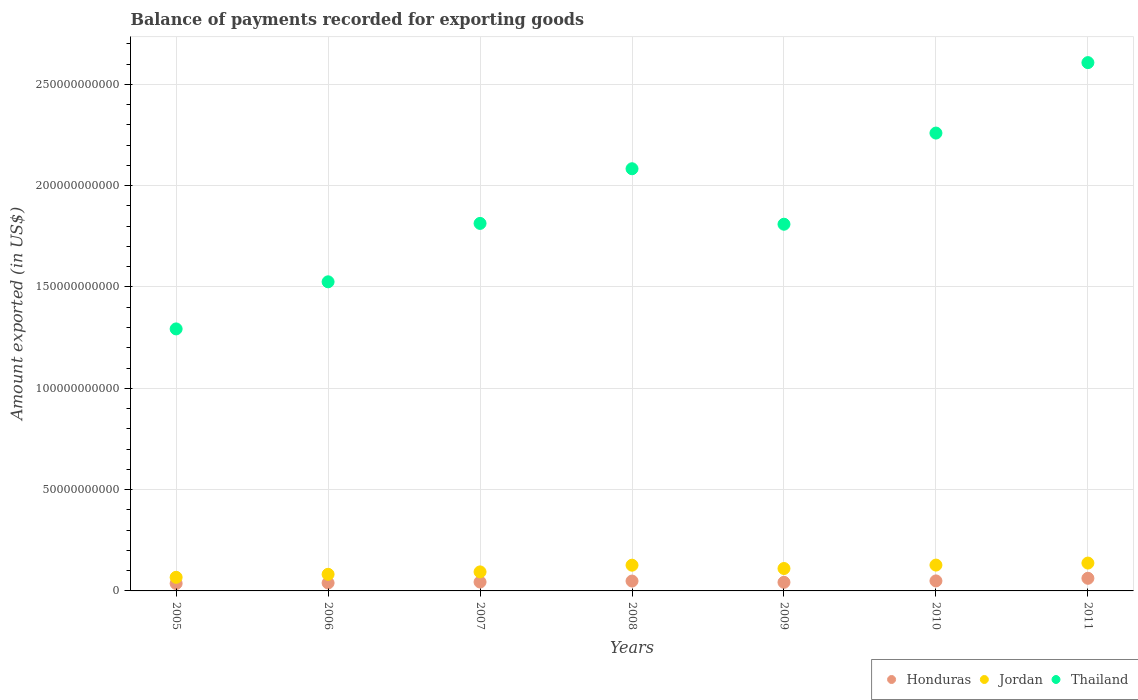How many different coloured dotlines are there?
Your response must be concise. 3. What is the amount exported in Honduras in 2005?
Keep it short and to the point. 3.67e+09. Across all years, what is the maximum amount exported in Honduras?
Your answer should be very brief. 6.23e+09. Across all years, what is the minimum amount exported in Jordan?
Your answer should be very brief. 6.71e+09. What is the total amount exported in Thailand in the graph?
Keep it short and to the point. 1.34e+12. What is the difference between the amount exported in Honduras in 2006 and that in 2008?
Your answer should be compact. -9.28e+08. What is the difference between the amount exported in Honduras in 2006 and the amount exported in Jordan in 2007?
Ensure brevity in your answer.  -5.45e+09. What is the average amount exported in Thailand per year?
Your answer should be very brief. 1.91e+11. In the year 2005, what is the difference between the amount exported in Thailand and amount exported in Jordan?
Offer a terse response. 1.23e+11. What is the ratio of the amount exported in Honduras in 2006 to that in 2010?
Provide a short and direct response. 0.8. Is the amount exported in Thailand in 2010 less than that in 2011?
Provide a succinct answer. Yes. Is the difference between the amount exported in Thailand in 2005 and 2010 greater than the difference between the amount exported in Jordan in 2005 and 2010?
Keep it short and to the point. No. What is the difference between the highest and the second highest amount exported in Thailand?
Keep it short and to the point. 3.48e+1. What is the difference between the highest and the lowest amount exported in Jordan?
Provide a short and direct response. 7.03e+09. Is the sum of the amount exported in Thailand in 2008 and 2009 greater than the maximum amount exported in Jordan across all years?
Ensure brevity in your answer.  Yes. Is it the case that in every year, the sum of the amount exported in Jordan and amount exported in Honduras  is greater than the amount exported in Thailand?
Your answer should be compact. No. Is the amount exported in Thailand strictly less than the amount exported in Honduras over the years?
Keep it short and to the point. No. How many dotlines are there?
Offer a very short reply. 3. How many years are there in the graph?
Provide a succinct answer. 7. Does the graph contain any zero values?
Your response must be concise. No. Where does the legend appear in the graph?
Your answer should be very brief. Bottom right. What is the title of the graph?
Provide a short and direct response. Balance of payments recorded for exporting goods. Does "Bahrain" appear as one of the legend labels in the graph?
Your answer should be compact. No. What is the label or title of the Y-axis?
Provide a succinct answer. Amount exported (in US$). What is the Amount exported (in US$) in Honduras in 2005?
Ensure brevity in your answer.  3.67e+09. What is the Amount exported (in US$) of Jordan in 2005?
Make the answer very short. 6.71e+09. What is the Amount exported (in US$) in Thailand in 2005?
Your response must be concise. 1.29e+11. What is the Amount exported (in US$) in Honduras in 2006?
Provide a short and direct response. 3.94e+09. What is the Amount exported (in US$) in Jordan in 2006?
Your answer should be compact. 8.20e+09. What is the Amount exported (in US$) in Thailand in 2006?
Make the answer very short. 1.53e+11. What is the Amount exported (in US$) in Honduras in 2007?
Offer a terse response. 4.38e+09. What is the Amount exported (in US$) of Jordan in 2007?
Your response must be concise. 9.39e+09. What is the Amount exported (in US$) in Thailand in 2007?
Offer a terse response. 1.81e+11. What is the Amount exported (in US$) in Honduras in 2008?
Your response must be concise. 4.87e+09. What is the Amount exported (in US$) of Jordan in 2008?
Offer a very short reply. 1.27e+1. What is the Amount exported (in US$) of Thailand in 2008?
Your answer should be very brief. 2.08e+11. What is the Amount exported (in US$) of Honduras in 2009?
Offer a very short reply. 4.25e+09. What is the Amount exported (in US$) of Jordan in 2009?
Give a very brief answer. 1.11e+1. What is the Amount exported (in US$) in Thailand in 2009?
Make the answer very short. 1.81e+11. What is the Amount exported (in US$) in Honduras in 2010?
Offer a very short reply. 4.94e+09. What is the Amount exported (in US$) in Jordan in 2010?
Your answer should be very brief. 1.28e+1. What is the Amount exported (in US$) of Thailand in 2010?
Provide a short and direct response. 2.26e+11. What is the Amount exported (in US$) in Honduras in 2011?
Keep it short and to the point. 6.23e+09. What is the Amount exported (in US$) of Jordan in 2011?
Offer a very short reply. 1.37e+1. What is the Amount exported (in US$) of Thailand in 2011?
Provide a short and direct response. 2.61e+11. Across all years, what is the maximum Amount exported (in US$) in Honduras?
Ensure brevity in your answer.  6.23e+09. Across all years, what is the maximum Amount exported (in US$) in Jordan?
Keep it short and to the point. 1.37e+1. Across all years, what is the maximum Amount exported (in US$) in Thailand?
Provide a succinct answer. 2.61e+11. Across all years, what is the minimum Amount exported (in US$) in Honduras?
Your answer should be very brief. 3.67e+09. Across all years, what is the minimum Amount exported (in US$) in Jordan?
Your response must be concise. 6.71e+09. Across all years, what is the minimum Amount exported (in US$) in Thailand?
Your answer should be very brief. 1.29e+11. What is the total Amount exported (in US$) in Honduras in the graph?
Ensure brevity in your answer.  3.23e+1. What is the total Amount exported (in US$) in Jordan in the graph?
Your answer should be very brief. 7.46e+1. What is the total Amount exported (in US$) of Thailand in the graph?
Ensure brevity in your answer.  1.34e+12. What is the difference between the Amount exported (in US$) in Honduras in 2005 and that in 2006?
Make the answer very short. -2.66e+08. What is the difference between the Amount exported (in US$) of Jordan in 2005 and that in 2006?
Ensure brevity in your answer.  -1.49e+09. What is the difference between the Amount exported (in US$) in Thailand in 2005 and that in 2006?
Provide a short and direct response. -2.32e+1. What is the difference between the Amount exported (in US$) in Honduras in 2005 and that in 2007?
Your response must be concise. -7.13e+08. What is the difference between the Amount exported (in US$) of Jordan in 2005 and that in 2007?
Make the answer very short. -2.67e+09. What is the difference between the Amount exported (in US$) of Thailand in 2005 and that in 2007?
Keep it short and to the point. -5.21e+1. What is the difference between the Amount exported (in US$) in Honduras in 2005 and that in 2008?
Keep it short and to the point. -1.19e+09. What is the difference between the Amount exported (in US$) of Jordan in 2005 and that in 2008?
Your answer should be compact. -5.99e+09. What is the difference between the Amount exported (in US$) in Thailand in 2005 and that in 2008?
Give a very brief answer. -7.90e+1. What is the difference between the Amount exported (in US$) of Honduras in 2005 and that in 2009?
Your answer should be compact. -5.75e+08. What is the difference between the Amount exported (in US$) of Jordan in 2005 and that in 2009?
Your response must be concise. -4.35e+09. What is the difference between the Amount exported (in US$) in Thailand in 2005 and that in 2009?
Offer a terse response. -5.17e+1. What is the difference between the Amount exported (in US$) in Honduras in 2005 and that in 2010?
Offer a very short reply. -1.27e+09. What is the difference between the Amount exported (in US$) of Jordan in 2005 and that in 2010?
Your answer should be compact. -6.04e+09. What is the difference between the Amount exported (in US$) of Thailand in 2005 and that in 2010?
Your answer should be very brief. -9.66e+1. What is the difference between the Amount exported (in US$) of Honduras in 2005 and that in 2011?
Ensure brevity in your answer.  -2.56e+09. What is the difference between the Amount exported (in US$) of Jordan in 2005 and that in 2011?
Give a very brief answer. -7.03e+09. What is the difference between the Amount exported (in US$) in Thailand in 2005 and that in 2011?
Keep it short and to the point. -1.31e+11. What is the difference between the Amount exported (in US$) of Honduras in 2006 and that in 2007?
Give a very brief answer. -4.47e+08. What is the difference between the Amount exported (in US$) of Jordan in 2006 and that in 2007?
Provide a succinct answer. -1.19e+09. What is the difference between the Amount exported (in US$) of Thailand in 2006 and that in 2007?
Keep it short and to the point. -2.88e+1. What is the difference between the Amount exported (in US$) of Honduras in 2006 and that in 2008?
Provide a succinct answer. -9.28e+08. What is the difference between the Amount exported (in US$) of Jordan in 2006 and that in 2008?
Your answer should be very brief. -4.50e+09. What is the difference between the Amount exported (in US$) of Thailand in 2006 and that in 2008?
Give a very brief answer. -5.58e+1. What is the difference between the Amount exported (in US$) in Honduras in 2006 and that in 2009?
Make the answer very short. -3.09e+08. What is the difference between the Amount exported (in US$) of Jordan in 2006 and that in 2009?
Offer a very short reply. -2.86e+09. What is the difference between the Amount exported (in US$) in Thailand in 2006 and that in 2009?
Give a very brief answer. -2.84e+1. What is the difference between the Amount exported (in US$) of Honduras in 2006 and that in 2010?
Your answer should be compact. -1.00e+09. What is the difference between the Amount exported (in US$) of Jordan in 2006 and that in 2010?
Offer a terse response. -4.55e+09. What is the difference between the Amount exported (in US$) of Thailand in 2006 and that in 2010?
Provide a succinct answer. -7.34e+1. What is the difference between the Amount exported (in US$) in Honduras in 2006 and that in 2011?
Offer a very short reply. -2.29e+09. What is the difference between the Amount exported (in US$) of Jordan in 2006 and that in 2011?
Your answer should be very brief. -5.54e+09. What is the difference between the Amount exported (in US$) of Thailand in 2006 and that in 2011?
Offer a very short reply. -1.08e+11. What is the difference between the Amount exported (in US$) in Honduras in 2007 and that in 2008?
Your response must be concise. -4.81e+08. What is the difference between the Amount exported (in US$) of Jordan in 2007 and that in 2008?
Offer a very short reply. -3.31e+09. What is the difference between the Amount exported (in US$) in Thailand in 2007 and that in 2008?
Offer a terse response. -2.70e+1. What is the difference between the Amount exported (in US$) of Honduras in 2007 and that in 2009?
Offer a very short reply. 1.38e+08. What is the difference between the Amount exported (in US$) of Jordan in 2007 and that in 2009?
Give a very brief answer. -1.67e+09. What is the difference between the Amount exported (in US$) in Thailand in 2007 and that in 2009?
Give a very brief answer. 4.05e+08. What is the difference between the Amount exported (in US$) in Honduras in 2007 and that in 2010?
Keep it short and to the point. -5.55e+08. What is the difference between the Amount exported (in US$) in Jordan in 2007 and that in 2010?
Make the answer very short. -3.36e+09. What is the difference between the Amount exported (in US$) of Thailand in 2007 and that in 2010?
Provide a short and direct response. -4.46e+1. What is the difference between the Amount exported (in US$) in Honduras in 2007 and that in 2011?
Your answer should be very brief. -1.85e+09. What is the difference between the Amount exported (in US$) of Jordan in 2007 and that in 2011?
Provide a short and direct response. -4.36e+09. What is the difference between the Amount exported (in US$) in Thailand in 2007 and that in 2011?
Your answer should be compact. -7.93e+1. What is the difference between the Amount exported (in US$) in Honduras in 2008 and that in 2009?
Make the answer very short. 6.19e+08. What is the difference between the Amount exported (in US$) of Jordan in 2008 and that in 2009?
Make the answer very short. 1.64e+09. What is the difference between the Amount exported (in US$) in Thailand in 2008 and that in 2009?
Give a very brief answer. 2.74e+1. What is the difference between the Amount exported (in US$) in Honduras in 2008 and that in 2010?
Your answer should be compact. -7.41e+07. What is the difference between the Amount exported (in US$) of Jordan in 2008 and that in 2010?
Keep it short and to the point. -5.28e+07. What is the difference between the Amount exported (in US$) in Thailand in 2008 and that in 2010?
Make the answer very short. -1.76e+1. What is the difference between the Amount exported (in US$) of Honduras in 2008 and that in 2011?
Give a very brief answer. -1.37e+09. What is the difference between the Amount exported (in US$) in Jordan in 2008 and that in 2011?
Offer a terse response. -1.04e+09. What is the difference between the Amount exported (in US$) in Thailand in 2008 and that in 2011?
Provide a short and direct response. -5.24e+1. What is the difference between the Amount exported (in US$) in Honduras in 2009 and that in 2010?
Your response must be concise. -6.93e+08. What is the difference between the Amount exported (in US$) in Jordan in 2009 and that in 2010?
Provide a short and direct response. -1.69e+09. What is the difference between the Amount exported (in US$) of Thailand in 2009 and that in 2010?
Make the answer very short. -4.50e+1. What is the difference between the Amount exported (in US$) in Honduras in 2009 and that in 2011?
Provide a succinct answer. -1.99e+09. What is the difference between the Amount exported (in US$) in Jordan in 2009 and that in 2011?
Ensure brevity in your answer.  -2.68e+09. What is the difference between the Amount exported (in US$) in Thailand in 2009 and that in 2011?
Give a very brief answer. -7.97e+1. What is the difference between the Amount exported (in US$) of Honduras in 2010 and that in 2011?
Your answer should be compact. -1.29e+09. What is the difference between the Amount exported (in US$) in Jordan in 2010 and that in 2011?
Make the answer very short. -9.92e+08. What is the difference between the Amount exported (in US$) in Thailand in 2010 and that in 2011?
Provide a short and direct response. -3.48e+1. What is the difference between the Amount exported (in US$) of Honduras in 2005 and the Amount exported (in US$) of Jordan in 2006?
Provide a short and direct response. -4.53e+09. What is the difference between the Amount exported (in US$) of Honduras in 2005 and the Amount exported (in US$) of Thailand in 2006?
Offer a terse response. -1.49e+11. What is the difference between the Amount exported (in US$) in Jordan in 2005 and the Amount exported (in US$) in Thailand in 2006?
Your answer should be very brief. -1.46e+11. What is the difference between the Amount exported (in US$) in Honduras in 2005 and the Amount exported (in US$) in Jordan in 2007?
Ensure brevity in your answer.  -5.72e+09. What is the difference between the Amount exported (in US$) in Honduras in 2005 and the Amount exported (in US$) in Thailand in 2007?
Keep it short and to the point. -1.78e+11. What is the difference between the Amount exported (in US$) in Jordan in 2005 and the Amount exported (in US$) in Thailand in 2007?
Give a very brief answer. -1.75e+11. What is the difference between the Amount exported (in US$) of Honduras in 2005 and the Amount exported (in US$) of Jordan in 2008?
Offer a terse response. -9.03e+09. What is the difference between the Amount exported (in US$) in Honduras in 2005 and the Amount exported (in US$) in Thailand in 2008?
Your answer should be very brief. -2.05e+11. What is the difference between the Amount exported (in US$) in Jordan in 2005 and the Amount exported (in US$) in Thailand in 2008?
Give a very brief answer. -2.02e+11. What is the difference between the Amount exported (in US$) of Honduras in 2005 and the Amount exported (in US$) of Jordan in 2009?
Provide a succinct answer. -7.39e+09. What is the difference between the Amount exported (in US$) in Honduras in 2005 and the Amount exported (in US$) in Thailand in 2009?
Your response must be concise. -1.77e+11. What is the difference between the Amount exported (in US$) of Jordan in 2005 and the Amount exported (in US$) of Thailand in 2009?
Offer a terse response. -1.74e+11. What is the difference between the Amount exported (in US$) of Honduras in 2005 and the Amount exported (in US$) of Jordan in 2010?
Keep it short and to the point. -9.08e+09. What is the difference between the Amount exported (in US$) of Honduras in 2005 and the Amount exported (in US$) of Thailand in 2010?
Keep it short and to the point. -2.22e+11. What is the difference between the Amount exported (in US$) in Jordan in 2005 and the Amount exported (in US$) in Thailand in 2010?
Your answer should be very brief. -2.19e+11. What is the difference between the Amount exported (in US$) of Honduras in 2005 and the Amount exported (in US$) of Jordan in 2011?
Ensure brevity in your answer.  -1.01e+1. What is the difference between the Amount exported (in US$) in Honduras in 2005 and the Amount exported (in US$) in Thailand in 2011?
Offer a terse response. -2.57e+11. What is the difference between the Amount exported (in US$) in Jordan in 2005 and the Amount exported (in US$) in Thailand in 2011?
Make the answer very short. -2.54e+11. What is the difference between the Amount exported (in US$) of Honduras in 2006 and the Amount exported (in US$) of Jordan in 2007?
Offer a terse response. -5.45e+09. What is the difference between the Amount exported (in US$) of Honduras in 2006 and the Amount exported (in US$) of Thailand in 2007?
Provide a succinct answer. -1.77e+11. What is the difference between the Amount exported (in US$) of Jordan in 2006 and the Amount exported (in US$) of Thailand in 2007?
Your response must be concise. -1.73e+11. What is the difference between the Amount exported (in US$) of Honduras in 2006 and the Amount exported (in US$) of Jordan in 2008?
Offer a terse response. -8.76e+09. What is the difference between the Amount exported (in US$) in Honduras in 2006 and the Amount exported (in US$) in Thailand in 2008?
Give a very brief answer. -2.04e+11. What is the difference between the Amount exported (in US$) of Jordan in 2006 and the Amount exported (in US$) of Thailand in 2008?
Give a very brief answer. -2.00e+11. What is the difference between the Amount exported (in US$) of Honduras in 2006 and the Amount exported (in US$) of Jordan in 2009?
Offer a very short reply. -7.12e+09. What is the difference between the Amount exported (in US$) of Honduras in 2006 and the Amount exported (in US$) of Thailand in 2009?
Make the answer very short. -1.77e+11. What is the difference between the Amount exported (in US$) in Jordan in 2006 and the Amount exported (in US$) in Thailand in 2009?
Offer a very short reply. -1.73e+11. What is the difference between the Amount exported (in US$) of Honduras in 2006 and the Amount exported (in US$) of Jordan in 2010?
Offer a terse response. -8.81e+09. What is the difference between the Amount exported (in US$) in Honduras in 2006 and the Amount exported (in US$) in Thailand in 2010?
Provide a short and direct response. -2.22e+11. What is the difference between the Amount exported (in US$) in Jordan in 2006 and the Amount exported (in US$) in Thailand in 2010?
Keep it short and to the point. -2.18e+11. What is the difference between the Amount exported (in US$) of Honduras in 2006 and the Amount exported (in US$) of Jordan in 2011?
Keep it short and to the point. -9.81e+09. What is the difference between the Amount exported (in US$) in Honduras in 2006 and the Amount exported (in US$) in Thailand in 2011?
Offer a very short reply. -2.57e+11. What is the difference between the Amount exported (in US$) in Jordan in 2006 and the Amount exported (in US$) in Thailand in 2011?
Your answer should be very brief. -2.52e+11. What is the difference between the Amount exported (in US$) in Honduras in 2007 and the Amount exported (in US$) in Jordan in 2008?
Provide a short and direct response. -8.31e+09. What is the difference between the Amount exported (in US$) of Honduras in 2007 and the Amount exported (in US$) of Thailand in 2008?
Ensure brevity in your answer.  -2.04e+11. What is the difference between the Amount exported (in US$) of Jordan in 2007 and the Amount exported (in US$) of Thailand in 2008?
Offer a very short reply. -1.99e+11. What is the difference between the Amount exported (in US$) of Honduras in 2007 and the Amount exported (in US$) of Jordan in 2009?
Keep it short and to the point. -6.68e+09. What is the difference between the Amount exported (in US$) of Honduras in 2007 and the Amount exported (in US$) of Thailand in 2009?
Your response must be concise. -1.77e+11. What is the difference between the Amount exported (in US$) of Jordan in 2007 and the Amount exported (in US$) of Thailand in 2009?
Offer a terse response. -1.72e+11. What is the difference between the Amount exported (in US$) of Honduras in 2007 and the Amount exported (in US$) of Jordan in 2010?
Offer a terse response. -8.37e+09. What is the difference between the Amount exported (in US$) of Honduras in 2007 and the Amount exported (in US$) of Thailand in 2010?
Your answer should be compact. -2.22e+11. What is the difference between the Amount exported (in US$) of Jordan in 2007 and the Amount exported (in US$) of Thailand in 2010?
Provide a short and direct response. -2.17e+11. What is the difference between the Amount exported (in US$) in Honduras in 2007 and the Amount exported (in US$) in Jordan in 2011?
Your response must be concise. -9.36e+09. What is the difference between the Amount exported (in US$) of Honduras in 2007 and the Amount exported (in US$) of Thailand in 2011?
Provide a short and direct response. -2.56e+11. What is the difference between the Amount exported (in US$) of Jordan in 2007 and the Amount exported (in US$) of Thailand in 2011?
Give a very brief answer. -2.51e+11. What is the difference between the Amount exported (in US$) in Honduras in 2008 and the Amount exported (in US$) in Jordan in 2009?
Your response must be concise. -6.20e+09. What is the difference between the Amount exported (in US$) in Honduras in 2008 and the Amount exported (in US$) in Thailand in 2009?
Offer a terse response. -1.76e+11. What is the difference between the Amount exported (in US$) in Jordan in 2008 and the Amount exported (in US$) in Thailand in 2009?
Your response must be concise. -1.68e+11. What is the difference between the Amount exported (in US$) of Honduras in 2008 and the Amount exported (in US$) of Jordan in 2010?
Offer a very short reply. -7.89e+09. What is the difference between the Amount exported (in US$) of Honduras in 2008 and the Amount exported (in US$) of Thailand in 2010?
Provide a short and direct response. -2.21e+11. What is the difference between the Amount exported (in US$) in Jordan in 2008 and the Amount exported (in US$) in Thailand in 2010?
Keep it short and to the point. -2.13e+11. What is the difference between the Amount exported (in US$) of Honduras in 2008 and the Amount exported (in US$) of Jordan in 2011?
Offer a very short reply. -8.88e+09. What is the difference between the Amount exported (in US$) in Honduras in 2008 and the Amount exported (in US$) in Thailand in 2011?
Make the answer very short. -2.56e+11. What is the difference between the Amount exported (in US$) of Jordan in 2008 and the Amount exported (in US$) of Thailand in 2011?
Provide a succinct answer. -2.48e+11. What is the difference between the Amount exported (in US$) in Honduras in 2009 and the Amount exported (in US$) in Jordan in 2010?
Your answer should be very brief. -8.51e+09. What is the difference between the Amount exported (in US$) in Honduras in 2009 and the Amount exported (in US$) in Thailand in 2010?
Make the answer very short. -2.22e+11. What is the difference between the Amount exported (in US$) in Jordan in 2009 and the Amount exported (in US$) in Thailand in 2010?
Make the answer very short. -2.15e+11. What is the difference between the Amount exported (in US$) of Honduras in 2009 and the Amount exported (in US$) of Jordan in 2011?
Your answer should be very brief. -9.50e+09. What is the difference between the Amount exported (in US$) of Honduras in 2009 and the Amount exported (in US$) of Thailand in 2011?
Provide a short and direct response. -2.56e+11. What is the difference between the Amount exported (in US$) of Jordan in 2009 and the Amount exported (in US$) of Thailand in 2011?
Offer a terse response. -2.50e+11. What is the difference between the Amount exported (in US$) in Honduras in 2010 and the Amount exported (in US$) in Jordan in 2011?
Provide a short and direct response. -8.80e+09. What is the difference between the Amount exported (in US$) of Honduras in 2010 and the Amount exported (in US$) of Thailand in 2011?
Ensure brevity in your answer.  -2.56e+11. What is the difference between the Amount exported (in US$) of Jordan in 2010 and the Amount exported (in US$) of Thailand in 2011?
Ensure brevity in your answer.  -2.48e+11. What is the average Amount exported (in US$) of Honduras per year?
Ensure brevity in your answer.  4.61e+09. What is the average Amount exported (in US$) in Jordan per year?
Make the answer very short. 1.07e+1. What is the average Amount exported (in US$) of Thailand per year?
Keep it short and to the point. 1.91e+11. In the year 2005, what is the difference between the Amount exported (in US$) of Honduras and Amount exported (in US$) of Jordan?
Ensure brevity in your answer.  -3.04e+09. In the year 2005, what is the difference between the Amount exported (in US$) of Honduras and Amount exported (in US$) of Thailand?
Your answer should be very brief. -1.26e+11. In the year 2005, what is the difference between the Amount exported (in US$) of Jordan and Amount exported (in US$) of Thailand?
Your response must be concise. -1.23e+11. In the year 2006, what is the difference between the Amount exported (in US$) in Honduras and Amount exported (in US$) in Jordan?
Offer a very short reply. -4.26e+09. In the year 2006, what is the difference between the Amount exported (in US$) in Honduras and Amount exported (in US$) in Thailand?
Keep it short and to the point. -1.49e+11. In the year 2006, what is the difference between the Amount exported (in US$) of Jordan and Amount exported (in US$) of Thailand?
Provide a short and direct response. -1.44e+11. In the year 2007, what is the difference between the Amount exported (in US$) in Honduras and Amount exported (in US$) in Jordan?
Provide a succinct answer. -5.00e+09. In the year 2007, what is the difference between the Amount exported (in US$) of Honduras and Amount exported (in US$) of Thailand?
Make the answer very short. -1.77e+11. In the year 2007, what is the difference between the Amount exported (in US$) of Jordan and Amount exported (in US$) of Thailand?
Your response must be concise. -1.72e+11. In the year 2008, what is the difference between the Amount exported (in US$) in Honduras and Amount exported (in US$) in Jordan?
Offer a terse response. -7.83e+09. In the year 2008, what is the difference between the Amount exported (in US$) in Honduras and Amount exported (in US$) in Thailand?
Provide a succinct answer. -2.03e+11. In the year 2008, what is the difference between the Amount exported (in US$) in Jordan and Amount exported (in US$) in Thailand?
Provide a short and direct response. -1.96e+11. In the year 2009, what is the difference between the Amount exported (in US$) of Honduras and Amount exported (in US$) of Jordan?
Your answer should be compact. -6.81e+09. In the year 2009, what is the difference between the Amount exported (in US$) of Honduras and Amount exported (in US$) of Thailand?
Provide a succinct answer. -1.77e+11. In the year 2009, what is the difference between the Amount exported (in US$) in Jordan and Amount exported (in US$) in Thailand?
Keep it short and to the point. -1.70e+11. In the year 2010, what is the difference between the Amount exported (in US$) of Honduras and Amount exported (in US$) of Jordan?
Provide a succinct answer. -7.81e+09. In the year 2010, what is the difference between the Amount exported (in US$) of Honduras and Amount exported (in US$) of Thailand?
Your answer should be very brief. -2.21e+11. In the year 2010, what is the difference between the Amount exported (in US$) of Jordan and Amount exported (in US$) of Thailand?
Provide a short and direct response. -2.13e+11. In the year 2011, what is the difference between the Amount exported (in US$) in Honduras and Amount exported (in US$) in Jordan?
Keep it short and to the point. -7.51e+09. In the year 2011, what is the difference between the Amount exported (in US$) of Honduras and Amount exported (in US$) of Thailand?
Provide a short and direct response. -2.54e+11. In the year 2011, what is the difference between the Amount exported (in US$) of Jordan and Amount exported (in US$) of Thailand?
Offer a terse response. -2.47e+11. What is the ratio of the Amount exported (in US$) in Honduras in 2005 to that in 2006?
Give a very brief answer. 0.93. What is the ratio of the Amount exported (in US$) in Jordan in 2005 to that in 2006?
Provide a succinct answer. 0.82. What is the ratio of the Amount exported (in US$) in Thailand in 2005 to that in 2006?
Your answer should be compact. 0.85. What is the ratio of the Amount exported (in US$) in Honduras in 2005 to that in 2007?
Keep it short and to the point. 0.84. What is the ratio of the Amount exported (in US$) of Jordan in 2005 to that in 2007?
Your response must be concise. 0.72. What is the ratio of the Amount exported (in US$) in Thailand in 2005 to that in 2007?
Offer a terse response. 0.71. What is the ratio of the Amount exported (in US$) of Honduras in 2005 to that in 2008?
Your response must be concise. 0.75. What is the ratio of the Amount exported (in US$) of Jordan in 2005 to that in 2008?
Keep it short and to the point. 0.53. What is the ratio of the Amount exported (in US$) of Thailand in 2005 to that in 2008?
Your answer should be very brief. 0.62. What is the ratio of the Amount exported (in US$) of Honduras in 2005 to that in 2009?
Ensure brevity in your answer.  0.86. What is the ratio of the Amount exported (in US$) of Jordan in 2005 to that in 2009?
Provide a succinct answer. 0.61. What is the ratio of the Amount exported (in US$) of Thailand in 2005 to that in 2009?
Your answer should be very brief. 0.71. What is the ratio of the Amount exported (in US$) in Honduras in 2005 to that in 2010?
Offer a very short reply. 0.74. What is the ratio of the Amount exported (in US$) of Jordan in 2005 to that in 2010?
Give a very brief answer. 0.53. What is the ratio of the Amount exported (in US$) in Thailand in 2005 to that in 2010?
Offer a terse response. 0.57. What is the ratio of the Amount exported (in US$) in Honduras in 2005 to that in 2011?
Give a very brief answer. 0.59. What is the ratio of the Amount exported (in US$) in Jordan in 2005 to that in 2011?
Provide a short and direct response. 0.49. What is the ratio of the Amount exported (in US$) in Thailand in 2005 to that in 2011?
Your response must be concise. 0.5. What is the ratio of the Amount exported (in US$) of Honduras in 2006 to that in 2007?
Make the answer very short. 0.9. What is the ratio of the Amount exported (in US$) of Jordan in 2006 to that in 2007?
Make the answer very short. 0.87. What is the ratio of the Amount exported (in US$) in Thailand in 2006 to that in 2007?
Give a very brief answer. 0.84. What is the ratio of the Amount exported (in US$) of Honduras in 2006 to that in 2008?
Your answer should be very brief. 0.81. What is the ratio of the Amount exported (in US$) in Jordan in 2006 to that in 2008?
Your answer should be very brief. 0.65. What is the ratio of the Amount exported (in US$) in Thailand in 2006 to that in 2008?
Your response must be concise. 0.73. What is the ratio of the Amount exported (in US$) of Honduras in 2006 to that in 2009?
Your answer should be very brief. 0.93. What is the ratio of the Amount exported (in US$) of Jordan in 2006 to that in 2009?
Your answer should be compact. 0.74. What is the ratio of the Amount exported (in US$) in Thailand in 2006 to that in 2009?
Make the answer very short. 0.84. What is the ratio of the Amount exported (in US$) in Honduras in 2006 to that in 2010?
Your answer should be compact. 0.8. What is the ratio of the Amount exported (in US$) in Jordan in 2006 to that in 2010?
Offer a terse response. 0.64. What is the ratio of the Amount exported (in US$) in Thailand in 2006 to that in 2010?
Offer a very short reply. 0.68. What is the ratio of the Amount exported (in US$) of Honduras in 2006 to that in 2011?
Keep it short and to the point. 0.63. What is the ratio of the Amount exported (in US$) in Jordan in 2006 to that in 2011?
Your answer should be very brief. 0.6. What is the ratio of the Amount exported (in US$) of Thailand in 2006 to that in 2011?
Ensure brevity in your answer.  0.59. What is the ratio of the Amount exported (in US$) in Honduras in 2007 to that in 2008?
Ensure brevity in your answer.  0.9. What is the ratio of the Amount exported (in US$) in Jordan in 2007 to that in 2008?
Provide a succinct answer. 0.74. What is the ratio of the Amount exported (in US$) in Thailand in 2007 to that in 2008?
Your answer should be very brief. 0.87. What is the ratio of the Amount exported (in US$) in Honduras in 2007 to that in 2009?
Offer a terse response. 1.03. What is the ratio of the Amount exported (in US$) in Jordan in 2007 to that in 2009?
Your response must be concise. 0.85. What is the ratio of the Amount exported (in US$) of Thailand in 2007 to that in 2009?
Your response must be concise. 1. What is the ratio of the Amount exported (in US$) in Honduras in 2007 to that in 2010?
Your answer should be compact. 0.89. What is the ratio of the Amount exported (in US$) of Jordan in 2007 to that in 2010?
Offer a terse response. 0.74. What is the ratio of the Amount exported (in US$) in Thailand in 2007 to that in 2010?
Your answer should be compact. 0.8. What is the ratio of the Amount exported (in US$) in Honduras in 2007 to that in 2011?
Your answer should be compact. 0.7. What is the ratio of the Amount exported (in US$) in Jordan in 2007 to that in 2011?
Offer a terse response. 0.68. What is the ratio of the Amount exported (in US$) of Thailand in 2007 to that in 2011?
Ensure brevity in your answer.  0.7. What is the ratio of the Amount exported (in US$) of Honduras in 2008 to that in 2009?
Keep it short and to the point. 1.15. What is the ratio of the Amount exported (in US$) in Jordan in 2008 to that in 2009?
Offer a very short reply. 1.15. What is the ratio of the Amount exported (in US$) of Thailand in 2008 to that in 2009?
Your answer should be compact. 1.15. What is the ratio of the Amount exported (in US$) in Thailand in 2008 to that in 2010?
Ensure brevity in your answer.  0.92. What is the ratio of the Amount exported (in US$) of Honduras in 2008 to that in 2011?
Provide a short and direct response. 0.78. What is the ratio of the Amount exported (in US$) of Jordan in 2008 to that in 2011?
Provide a short and direct response. 0.92. What is the ratio of the Amount exported (in US$) in Thailand in 2008 to that in 2011?
Offer a terse response. 0.8. What is the ratio of the Amount exported (in US$) of Honduras in 2009 to that in 2010?
Your answer should be very brief. 0.86. What is the ratio of the Amount exported (in US$) in Jordan in 2009 to that in 2010?
Ensure brevity in your answer.  0.87. What is the ratio of the Amount exported (in US$) in Thailand in 2009 to that in 2010?
Make the answer very short. 0.8. What is the ratio of the Amount exported (in US$) of Honduras in 2009 to that in 2011?
Provide a succinct answer. 0.68. What is the ratio of the Amount exported (in US$) in Jordan in 2009 to that in 2011?
Ensure brevity in your answer.  0.8. What is the ratio of the Amount exported (in US$) of Thailand in 2009 to that in 2011?
Keep it short and to the point. 0.69. What is the ratio of the Amount exported (in US$) of Honduras in 2010 to that in 2011?
Offer a very short reply. 0.79. What is the ratio of the Amount exported (in US$) in Jordan in 2010 to that in 2011?
Your response must be concise. 0.93. What is the ratio of the Amount exported (in US$) in Thailand in 2010 to that in 2011?
Offer a terse response. 0.87. What is the difference between the highest and the second highest Amount exported (in US$) of Honduras?
Provide a short and direct response. 1.29e+09. What is the difference between the highest and the second highest Amount exported (in US$) of Jordan?
Keep it short and to the point. 9.92e+08. What is the difference between the highest and the second highest Amount exported (in US$) of Thailand?
Offer a terse response. 3.48e+1. What is the difference between the highest and the lowest Amount exported (in US$) of Honduras?
Your answer should be compact. 2.56e+09. What is the difference between the highest and the lowest Amount exported (in US$) in Jordan?
Provide a succinct answer. 7.03e+09. What is the difference between the highest and the lowest Amount exported (in US$) in Thailand?
Keep it short and to the point. 1.31e+11. 